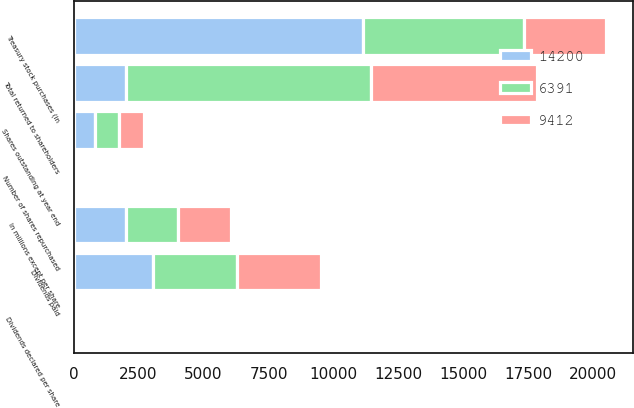Convert chart to OTSL. <chart><loc_0><loc_0><loc_500><loc_500><stacked_bar_chart><ecel><fcel>In millions except per share<fcel>Number of shares repurchased<fcel>Shares outstanding at year end<fcel>Dividends declared per share<fcel>Treasury stock purchases (in<fcel>Dividends paid<fcel>Total returned to shareholders<nl><fcel>14200<fcel>2016<fcel>92.3<fcel>819<fcel>3.61<fcel>11142<fcel>3058<fcel>2014.5<nl><fcel>6391<fcel>2015<fcel>61.8<fcel>907<fcel>3.44<fcel>6182<fcel>3230<fcel>9412<nl><fcel>9412<fcel>2014<fcel>33.1<fcel>963<fcel>3.28<fcel>3175<fcel>3216<fcel>6391<nl></chart> 